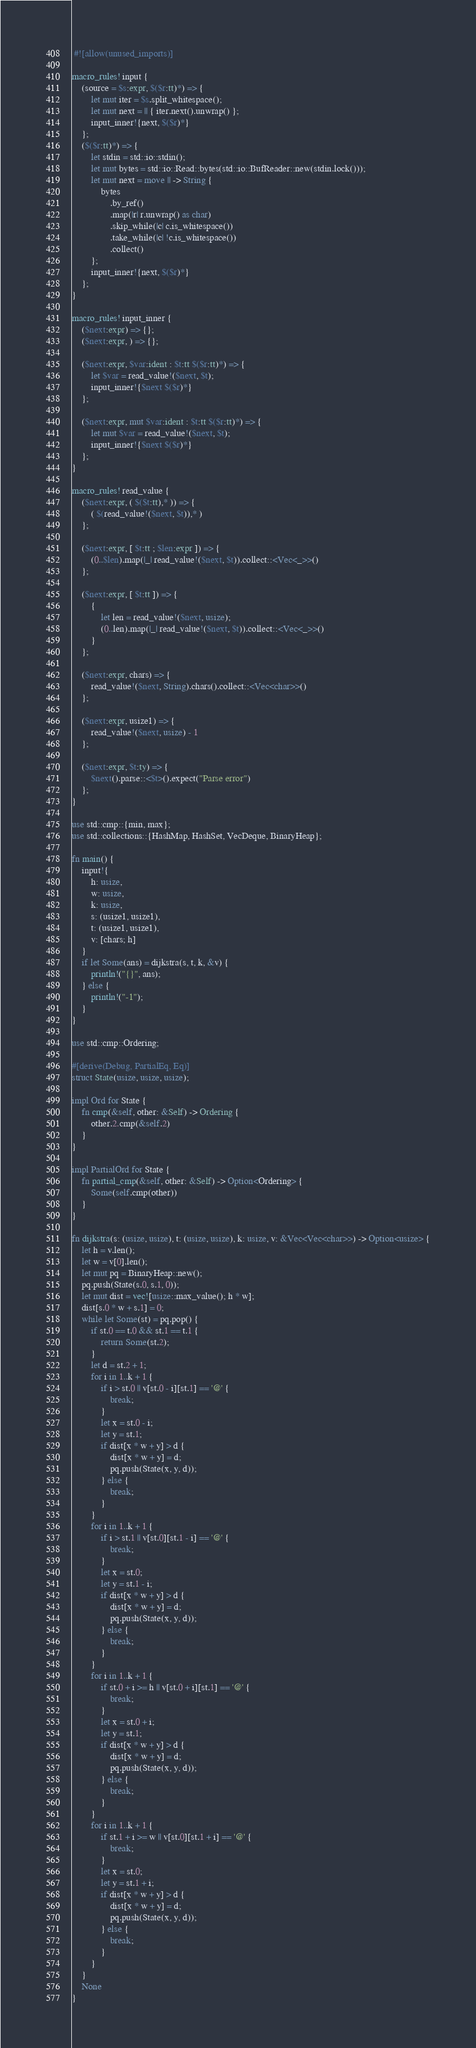Convert code to text. <code><loc_0><loc_0><loc_500><loc_500><_Rust_> #![allow(unused_imports)]

macro_rules! input {
    (source = $s:expr, $($r:tt)*) => {
        let mut iter = $s.split_whitespace();
        let mut next = || { iter.next().unwrap() };
        input_inner!{next, $($r)*}
    };
    ($($r:tt)*) => {
        let stdin = std::io::stdin();
        let mut bytes = std::io::Read::bytes(std::io::BufReader::new(stdin.lock()));
        let mut next = move || -> String {
            bytes
                .by_ref()
                .map(|r| r.unwrap() as char)
                .skip_while(|c| c.is_whitespace())
                .take_while(|c| !c.is_whitespace())
                .collect()
        };
        input_inner!{next, $($r)*}
    };
}

macro_rules! input_inner {
    ($next:expr) => {};
    ($next:expr, ) => {};

    ($next:expr, $var:ident : $t:tt $($r:tt)*) => {
        let $var = read_value!($next, $t);
        input_inner!{$next $($r)*}
    };

    ($next:expr, mut $var:ident : $t:tt $($r:tt)*) => {
        let mut $var = read_value!($next, $t);
        input_inner!{$next $($r)*}
    };
}

macro_rules! read_value {
    ($next:expr, ( $($t:tt),* )) => {
        ( $(read_value!($next, $t)),* )
    };

    ($next:expr, [ $t:tt ; $len:expr ]) => {
        (0..$len).map(|_| read_value!($next, $t)).collect::<Vec<_>>()
    };

    ($next:expr, [ $t:tt ]) => {
        {
            let len = read_value!($next, usize);
            (0..len).map(|_| read_value!($next, $t)).collect::<Vec<_>>()
        }
    };

    ($next:expr, chars) => {
        read_value!($next, String).chars().collect::<Vec<char>>()
    };

    ($next:expr, usize1) => {
        read_value!($next, usize) - 1
    };

    ($next:expr, $t:ty) => {
        $next().parse::<$t>().expect("Parse error")
    };
}

use std::cmp::{min, max};
use std::collections::{HashMap, HashSet, VecDeque, BinaryHeap};

fn main() {
    input!{
        h: usize,
        w: usize,
        k: usize,
        s: (usize1, usize1),
        t: (usize1, usize1),
        v: [chars; h]
    }
    if let Some(ans) = dijkstra(s, t, k, &v) {
        println!("{}", ans);
    } else {
        println!("-1");
    }
}

use std::cmp::Ordering;

#[derive(Debug, PartialEq, Eq)]
struct State(usize, usize, usize);

impl Ord for State {
    fn cmp(&self, other: &Self) -> Ordering {
        other.2.cmp(&self.2)
    }
}

impl PartialOrd for State {
    fn partial_cmp(&self, other: &Self) -> Option<Ordering> {
        Some(self.cmp(other))
    }
}

fn dijkstra(s: (usize, usize), t: (usize, usize), k: usize, v: &Vec<Vec<char>>) -> Option<usize> {
    let h = v.len();
    let w = v[0].len();
    let mut pq = BinaryHeap::new();
    pq.push(State(s.0, s.1, 0));
    let mut dist = vec![usize::max_value(); h * w];
    dist[s.0 * w + s.1] = 0;
    while let Some(st) = pq.pop() {
        if st.0 == t.0 && st.1 == t.1 {
            return Some(st.2);
        }
        let d = st.2 + 1;
        for i in 1..k + 1 {
            if i > st.0 || v[st.0 - i][st.1] == '@' {
                break;
            }
            let x = st.0 - i;
            let y = st.1;
            if dist[x * w + y] > d {
                dist[x * w + y] = d;
                pq.push(State(x, y, d));
            } else {
                break;
            }
        }
        for i in 1..k + 1 {
            if i > st.1 || v[st.0][st.1 - i] == '@' {
                break;
            }
            let x = st.0;
            let y = st.1 - i;
            if dist[x * w + y] > d {
                dist[x * w + y] = d;
                pq.push(State(x, y, d));
            } else {
                break;
            }
        }
        for i in 1..k + 1 {
            if st.0 + i >= h || v[st.0 + i][st.1] == '@' {
                break;
            }
            let x = st.0 + i;
            let y = st.1;
            if dist[x * w + y] > d {
                dist[x * w + y] = d;
                pq.push(State(x, y, d));
            } else {
                break;
            }
        }
        for i in 1..k + 1 {
            if st.1 + i >= w || v[st.0][st.1 + i] == '@' {
                break;
            }
            let x = st.0;
            let y = st.1 + i;
            if dist[x * w + y] > d {
                dist[x * w + y] = d;
                pq.push(State(x, y, d));
            } else {
                break;
            }
        }
    }
    None
}
</code> 